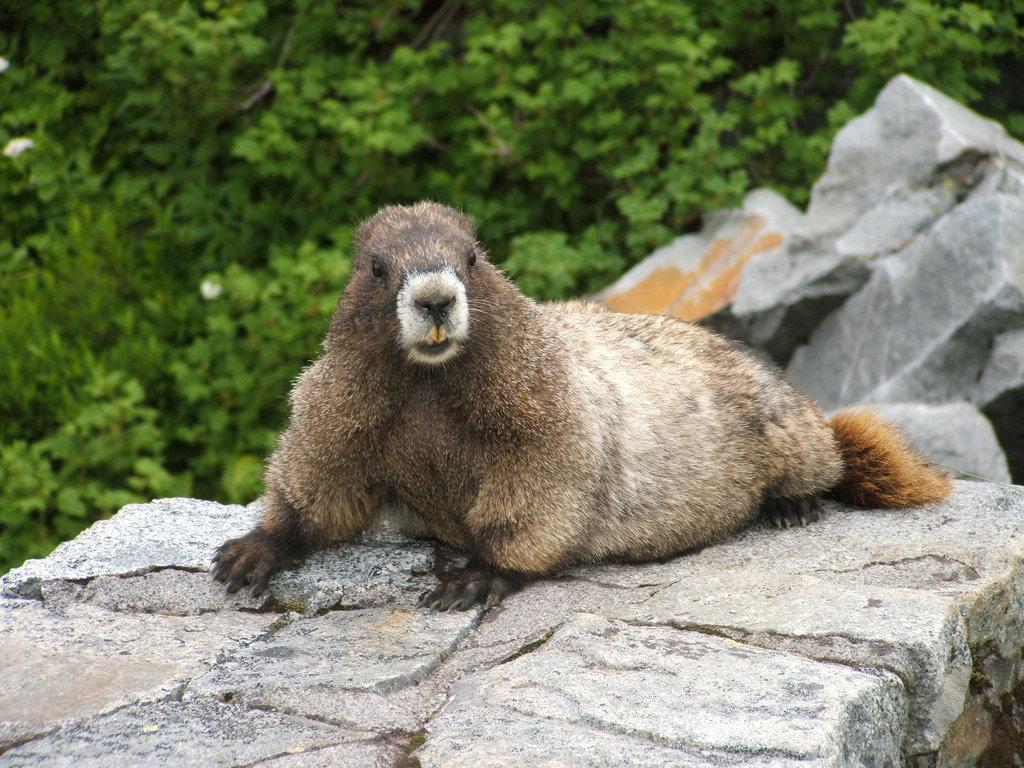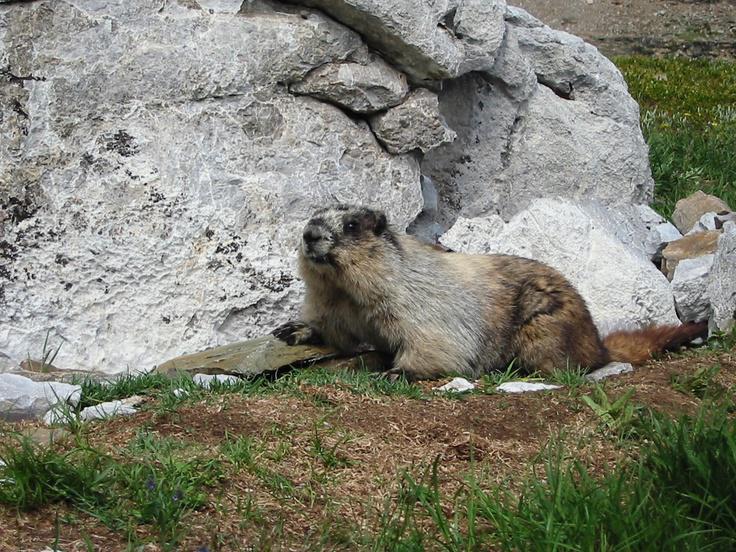The first image is the image on the left, the second image is the image on the right. Analyze the images presented: Is the assertion "The animal in the image on the right is on some form of vegetation." valid? Answer yes or no. Yes. 